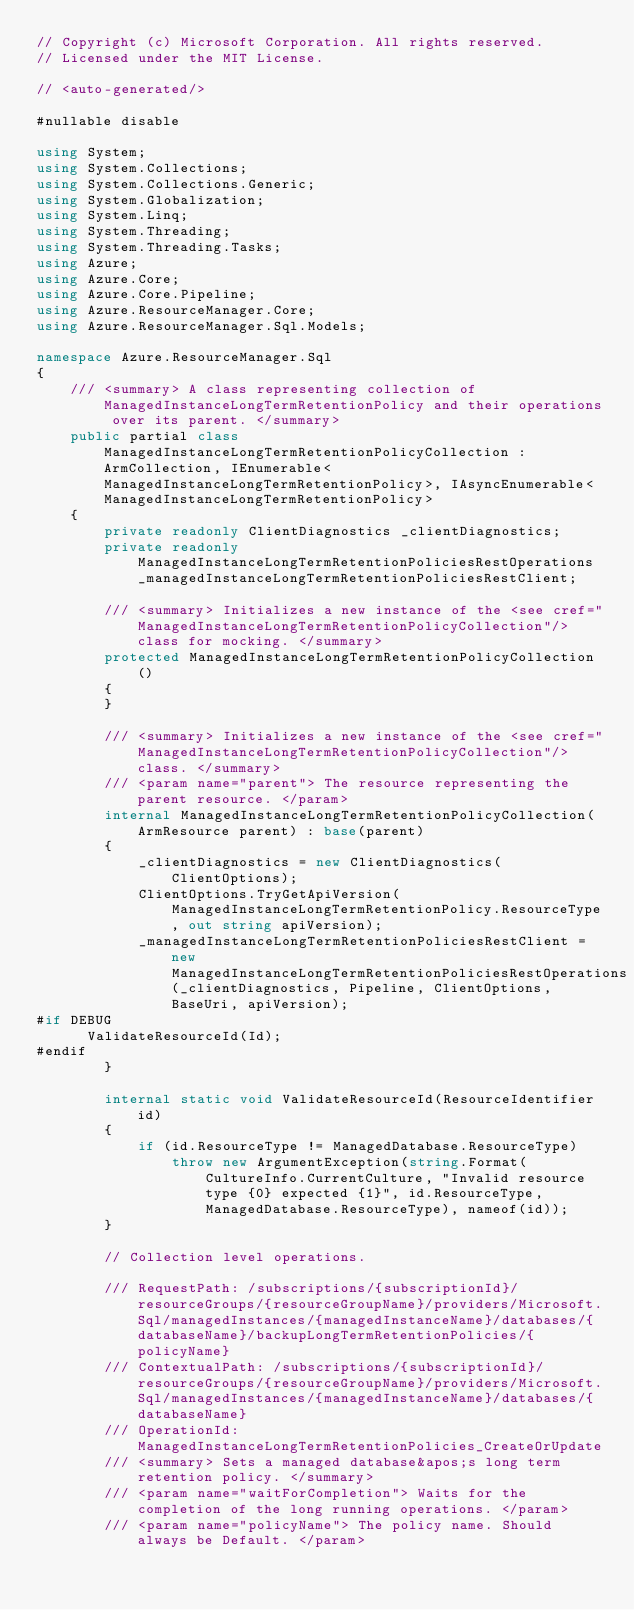Convert code to text. <code><loc_0><loc_0><loc_500><loc_500><_C#_>// Copyright (c) Microsoft Corporation. All rights reserved.
// Licensed under the MIT License.

// <auto-generated/>

#nullable disable

using System;
using System.Collections;
using System.Collections.Generic;
using System.Globalization;
using System.Linq;
using System.Threading;
using System.Threading.Tasks;
using Azure;
using Azure.Core;
using Azure.Core.Pipeline;
using Azure.ResourceManager.Core;
using Azure.ResourceManager.Sql.Models;

namespace Azure.ResourceManager.Sql
{
    /// <summary> A class representing collection of ManagedInstanceLongTermRetentionPolicy and their operations over its parent. </summary>
    public partial class ManagedInstanceLongTermRetentionPolicyCollection : ArmCollection, IEnumerable<ManagedInstanceLongTermRetentionPolicy>, IAsyncEnumerable<ManagedInstanceLongTermRetentionPolicy>
    {
        private readonly ClientDiagnostics _clientDiagnostics;
        private readonly ManagedInstanceLongTermRetentionPoliciesRestOperations _managedInstanceLongTermRetentionPoliciesRestClient;

        /// <summary> Initializes a new instance of the <see cref="ManagedInstanceLongTermRetentionPolicyCollection"/> class for mocking. </summary>
        protected ManagedInstanceLongTermRetentionPolicyCollection()
        {
        }

        /// <summary> Initializes a new instance of the <see cref="ManagedInstanceLongTermRetentionPolicyCollection"/> class. </summary>
        /// <param name="parent"> The resource representing the parent resource. </param>
        internal ManagedInstanceLongTermRetentionPolicyCollection(ArmResource parent) : base(parent)
        {
            _clientDiagnostics = new ClientDiagnostics(ClientOptions);
            ClientOptions.TryGetApiVersion(ManagedInstanceLongTermRetentionPolicy.ResourceType, out string apiVersion);
            _managedInstanceLongTermRetentionPoliciesRestClient = new ManagedInstanceLongTermRetentionPoliciesRestOperations(_clientDiagnostics, Pipeline, ClientOptions, BaseUri, apiVersion);
#if DEBUG
			ValidateResourceId(Id);
#endif
        }

        internal static void ValidateResourceId(ResourceIdentifier id)
        {
            if (id.ResourceType != ManagedDatabase.ResourceType)
                throw new ArgumentException(string.Format(CultureInfo.CurrentCulture, "Invalid resource type {0} expected {1}", id.ResourceType, ManagedDatabase.ResourceType), nameof(id));
        }

        // Collection level operations.

        /// RequestPath: /subscriptions/{subscriptionId}/resourceGroups/{resourceGroupName}/providers/Microsoft.Sql/managedInstances/{managedInstanceName}/databases/{databaseName}/backupLongTermRetentionPolicies/{policyName}
        /// ContextualPath: /subscriptions/{subscriptionId}/resourceGroups/{resourceGroupName}/providers/Microsoft.Sql/managedInstances/{managedInstanceName}/databases/{databaseName}
        /// OperationId: ManagedInstanceLongTermRetentionPolicies_CreateOrUpdate
        /// <summary> Sets a managed database&apos;s long term retention policy. </summary>
        /// <param name="waitForCompletion"> Waits for the completion of the long running operations. </param>
        /// <param name="policyName"> The policy name. Should always be Default. </param></code> 